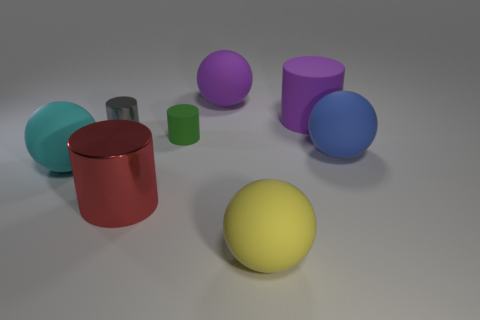Are there the same number of green cylinders behind the big purple ball and large gray metal cylinders?
Provide a short and direct response. Yes. What number of objects are either large red cylinders or big matte objects in front of the big purple sphere?
Offer a terse response. 5. Is there another large metallic thing that has the same shape as the big red thing?
Your answer should be compact. No. Are there an equal number of blue objects that are on the left side of the green matte thing and big purple matte spheres left of the yellow matte thing?
Offer a very short reply. No. How many purple objects are either big cylinders or shiny things?
Ensure brevity in your answer.  1. What number of green rubber objects are the same size as the gray metal object?
Your answer should be compact. 1. The cylinder that is both behind the small matte thing and right of the tiny gray metallic object is what color?
Offer a very short reply. Purple. Is the number of large rubber things in front of the cyan object greater than the number of blue rubber cubes?
Your answer should be very brief. Yes. Is there a yellow rubber thing?
Your answer should be compact. Yes. What number of large objects are blue rubber objects or purple cylinders?
Make the answer very short. 2. 